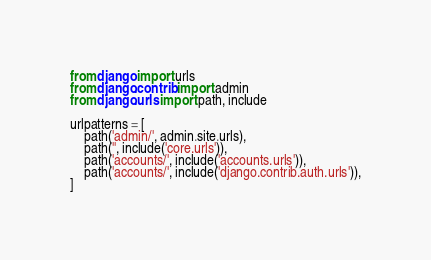<code> <loc_0><loc_0><loc_500><loc_500><_Python_>from django import urls
from django.contrib import admin
from django.urls import path, include

urlpatterns = [
    path('admin/', admin.site.urls),
    path('', include('core.urls')),
    path('accounts/', include('accounts.urls')),
    path('accounts/', include('django.contrib.auth.urls')),
]
</code> 